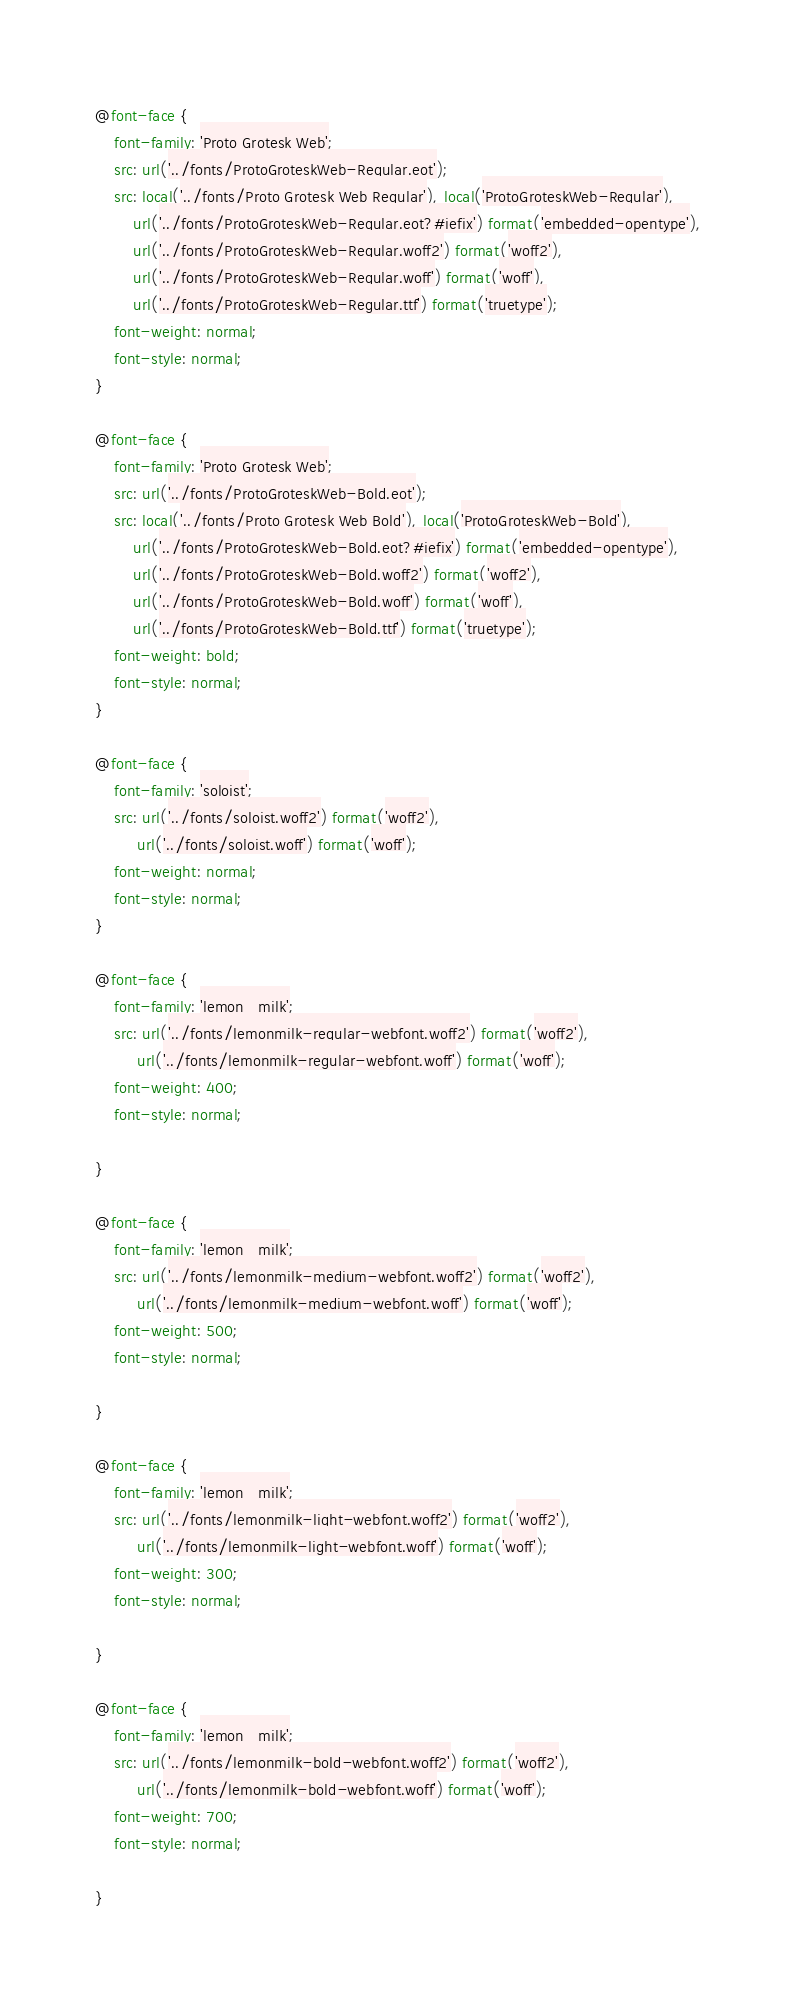Convert code to text. <code><loc_0><loc_0><loc_500><loc_500><_CSS_>@font-face {
    font-family: 'Proto Grotesk Web';
    src: url('../fonts/ProtoGroteskWeb-Regular.eot');
    src: local('../fonts/Proto Grotesk Web Regular'), local('ProtoGroteskWeb-Regular'),
        url('../fonts/ProtoGroteskWeb-Regular.eot?#iefix') format('embedded-opentype'),
        url('../fonts/ProtoGroteskWeb-Regular.woff2') format('woff2'),
        url('../fonts/ProtoGroteskWeb-Regular.woff') format('woff'),
        url('../fonts/ProtoGroteskWeb-Regular.ttf') format('truetype');
    font-weight: normal;
    font-style: normal;
}

@font-face {
    font-family: 'Proto Grotesk Web';
    src: url('../fonts/ProtoGroteskWeb-Bold.eot');
    src: local('../fonts/Proto Grotesk Web Bold'), local('ProtoGroteskWeb-Bold'),
        url('../fonts/ProtoGroteskWeb-Bold.eot?#iefix') format('embedded-opentype'),
        url('../fonts/ProtoGroteskWeb-Bold.woff2') format('woff2'),
        url('../fonts/ProtoGroteskWeb-Bold.woff') format('woff'),
        url('../fonts/ProtoGroteskWeb-Bold.ttf') format('truetype');
    font-weight: bold;
    font-style: normal;
}

@font-face {
    font-family: 'soloist';
    src: url('../fonts/soloist.woff2') format('woff2'),
         url('../fonts/soloist.woff') format('woff');
    font-weight: normal;
    font-style: normal;
}

@font-face {
    font-family: 'lemon_milk';
    src: url('../fonts/lemonmilk-regular-webfont.woff2') format('woff2'),
         url('../fonts/lemonmilk-regular-webfont.woff') format('woff');
    font-weight: 400;
    font-style: normal;

}

@font-face {
    font-family: 'lemon_milk';
    src: url('../fonts/lemonmilk-medium-webfont.woff2') format('woff2'),
         url('../fonts/lemonmilk-medium-webfont.woff') format('woff');
    font-weight: 500;
    font-style: normal;

}

@font-face {
    font-family: 'lemon_milk';
    src: url('../fonts/lemonmilk-light-webfont.woff2') format('woff2'),
         url('../fonts/lemonmilk-light-webfont.woff') format('woff');
    font-weight: 300;
    font-style: normal;

}

@font-face {
    font-family: 'lemon_milk';
    src: url('../fonts/lemonmilk-bold-webfont.woff2') format('woff2'),
         url('../fonts/lemonmilk-bold-webfont.woff') format('woff');
    font-weight: 700;
    font-style: normal;

}
</code> 